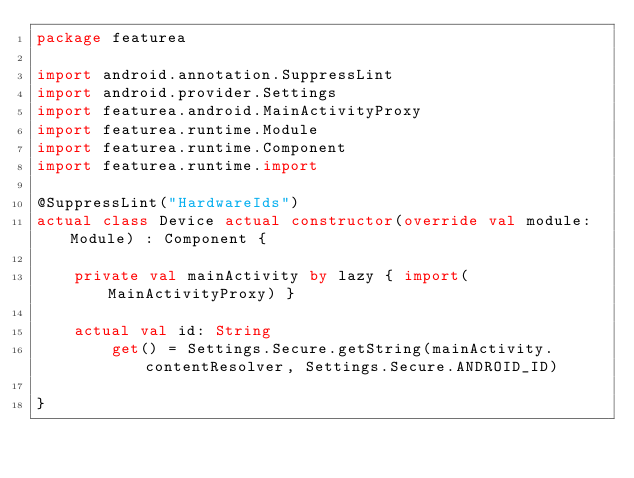Convert code to text. <code><loc_0><loc_0><loc_500><loc_500><_Kotlin_>package featurea

import android.annotation.SuppressLint
import android.provider.Settings
import featurea.android.MainActivityProxy
import featurea.runtime.Module
import featurea.runtime.Component
import featurea.runtime.import

@SuppressLint("HardwareIds")
actual class Device actual constructor(override val module: Module) : Component {

    private val mainActivity by lazy { import(MainActivityProxy) }

    actual val id: String
        get() = Settings.Secure.getString(mainActivity.contentResolver, Settings.Secure.ANDROID_ID)

}
</code> 